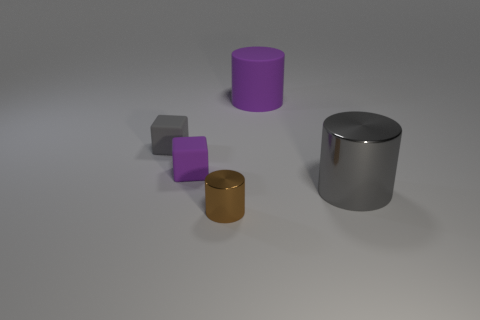Add 1 big purple balls. How many objects exist? 6 Subtract all cylinders. How many objects are left? 2 Add 5 big purple matte objects. How many big purple matte objects exist? 6 Subtract 0 red cylinders. How many objects are left? 5 Subtract all gray matte cubes. Subtract all large things. How many objects are left? 2 Add 4 purple matte cubes. How many purple matte cubes are left? 5 